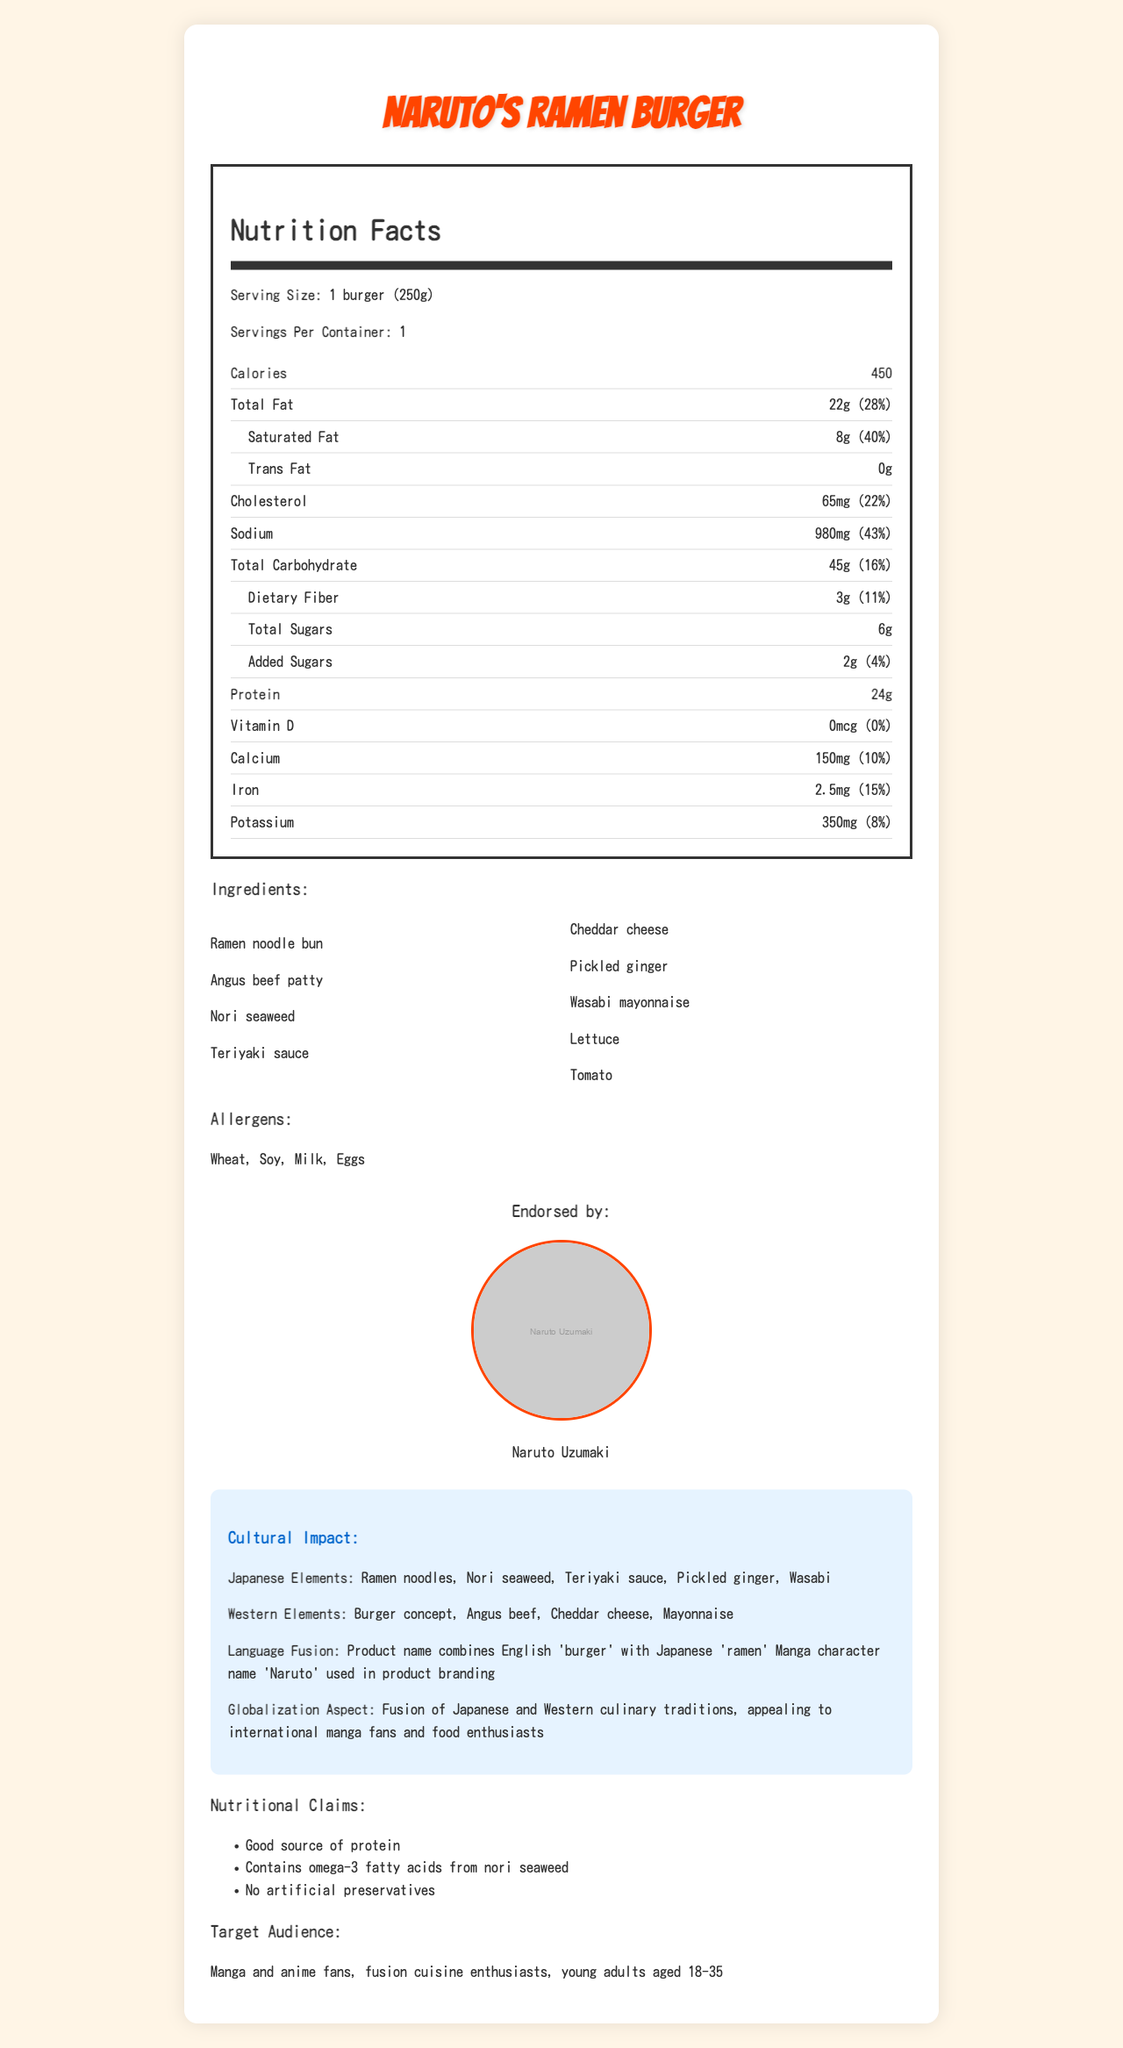What is the serving size for Naruto's Ramen Burger? The serving size is explicitly mentioned as "1 burger (250g)" in the Nutrition Facts section.
Answer: 1 burger (250g) How many calories are in a serving of Naruto's Ramen Burger? The document specifies that there are 450 calories per serving.
Answer: 450 What percentage of the daily value of saturated fat does one serving of Naruto's Ramen Burger contain? The saturated fat content is listed as 8g, which is 40% of the daily value.
Answer: 40% List three Japanese elements present in Naruto's Ramen Burger. The Japanese elements listed under cultural impact include Ramen noodles, Nori seaweed, Teriyaki sauce, Pickled ginger, and Wasabi.
Answer: Ramen noodles, Nori seaweed, Teriyaki sauce What are the allergens present in Naruto's Ramen Burger? The allergens section explicitly lists Wheat, Soy, Milk, and Eggs.
Answer: Wheat, Soy, Milk, Eggs Who is the manga character endorsement for Naruto's Ramen Burger? The document lists Naruto Uzumaki as the manga character endorsement for the product.
Answer: Naruto Uzumaki Which of the following is a nutritional claim made about Naruto's Ramen Burger? A. Low in calories B. Good source of protein C. Sugar-free The document lists "Good source of protein" as one of the nutritional claims.
Answer: B. Good source of protein What is the amount of added sugars in Naruto's Ramen Burger? A. 1g B. 2g C. 6g D. 0g The Nutrition Facts section states that the amount of added sugars is 2g.
Answer: B. 2g Does Naruto's Ramen Burger contain any artificial preservatives? The nutritional claims section states that the product has "No artificial preservatives."
Answer: No Provide a summary of the main idea of the document. The document describes Naruto's Ramen Burger, including its nutritional details, ingredients, cultural fusion elements, manga endorsement, and appeal to specific target audiences.
Answer: Naruto's Ramen Burger is a fusion cuisine product combining Japanese and Western flavors, endorsed by manga character Naruto Uzumaki. It provides detailed nutritional information, lists ingredients and allergens, and highlights its cultural impact and nutritional claims, targeting manga fans and fusion cuisine enthusiasts. How much sodium does one serving of Naruto's Ramen Burger contain, and what percentage of the daily value does this represent? The document specifies that one serving contains 980mg of sodium, which is 43% of the daily value.
Answer: 980mg, 43% What type of beef is used in Naruto's Ramen Burger? The ingredients list includes "Angus beef patty."
Answer: Angus beef What is the daily value percentage of calcium in Naruto's Ramen Burger? The Nutrition Facts section lists the amount of calcium and its daily value percentage as 10%.
Answer: 10% How does the product name reflect the fusion of Japanese and Western elements? The cultural impact section states that the product name reflects the fusion by combining English and Japanese elements.
Answer: The product name combines the English 'burger' with Japanese 'ramen' What is the manga character's role in the branding of Naruto's Ramen Burger? The manga character endorsement section indicates that Naruto Uzumaki endorses the product, contributing to its branding.
Answer: The manga character Naruto Uzumaki is used in product branding What are the primary target audiences for Naruto's Ramen Burger? The target audience section specifies manga and anime fans, fusion cuisine enthusiasts, and young adults aged 18-35 as primary audiences.
Answer: Manga and anime fans, fusion cuisine enthusiasts, young adults aged 18-35 What are the Western elements in Naruto's Ramen Burger? The cultural impact section lists the Western elements as Burger concept, Angus beef, Cheddar cheese, and Mayonnaise.
Answer: Burger concept, Angus beef, Cheddar cheese, Mayonnaise What type of dietary fiber is included, and what is its amount? The Nutrition Facts section states there is 3g of dietary fiber.
Answer: 3g of dietary fiber What is the amount of protein per serving in Naruto's Ramen Burger? The document lists the amount of protein per serving as 24g.
Answer: 24g Is Naruto's Ramen Burger suitable for individuals with nut allergies? The document lists allergens such as Wheat, Soy, Milk, and Eggs but does not mention nuts.
Answer: Not enough information Would a fusion cuisine enthusiast likely be interested in Naruto's Ramen Burger? The product is designed with fusion cuisine elements, making it appealing to fusion cuisine enthusiasts as mentioned in the cultural aspect and target audience sections.
Answer: Yes 